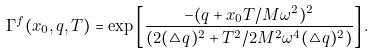<formula> <loc_0><loc_0><loc_500><loc_500>\Gamma ^ { f } ( x _ { 0 } , q , T ) = \exp \left [ \frac { - ( q + x _ { 0 } T / M \omega ^ { 2 } ) ^ { 2 } } { ( 2 ( \triangle q ) ^ { 2 } + T ^ { 2 } / 2 M ^ { 2 } \omega ^ { 4 } ( \triangle q ) ^ { 2 } ) } \right ] .</formula> 